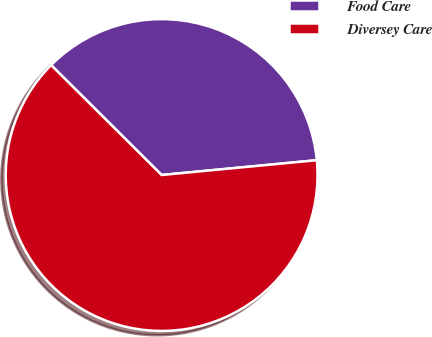<chart> <loc_0><loc_0><loc_500><loc_500><pie_chart><fcel>Food Care<fcel>Diversey Care<nl><fcel>36.03%<fcel>63.97%<nl></chart> 